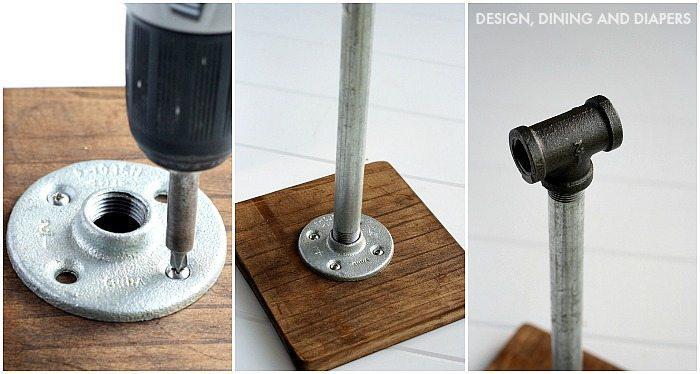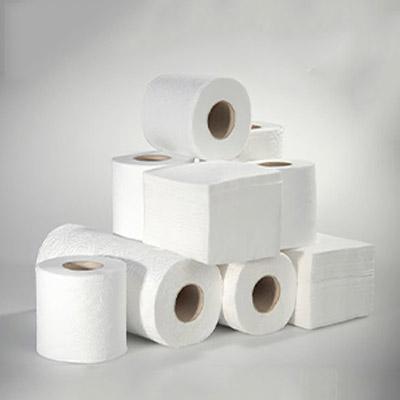The first image is the image on the left, the second image is the image on the right. For the images shown, is this caption "An image features some neatly stacked rolls of paper towels." true? Answer yes or no. Yes. 